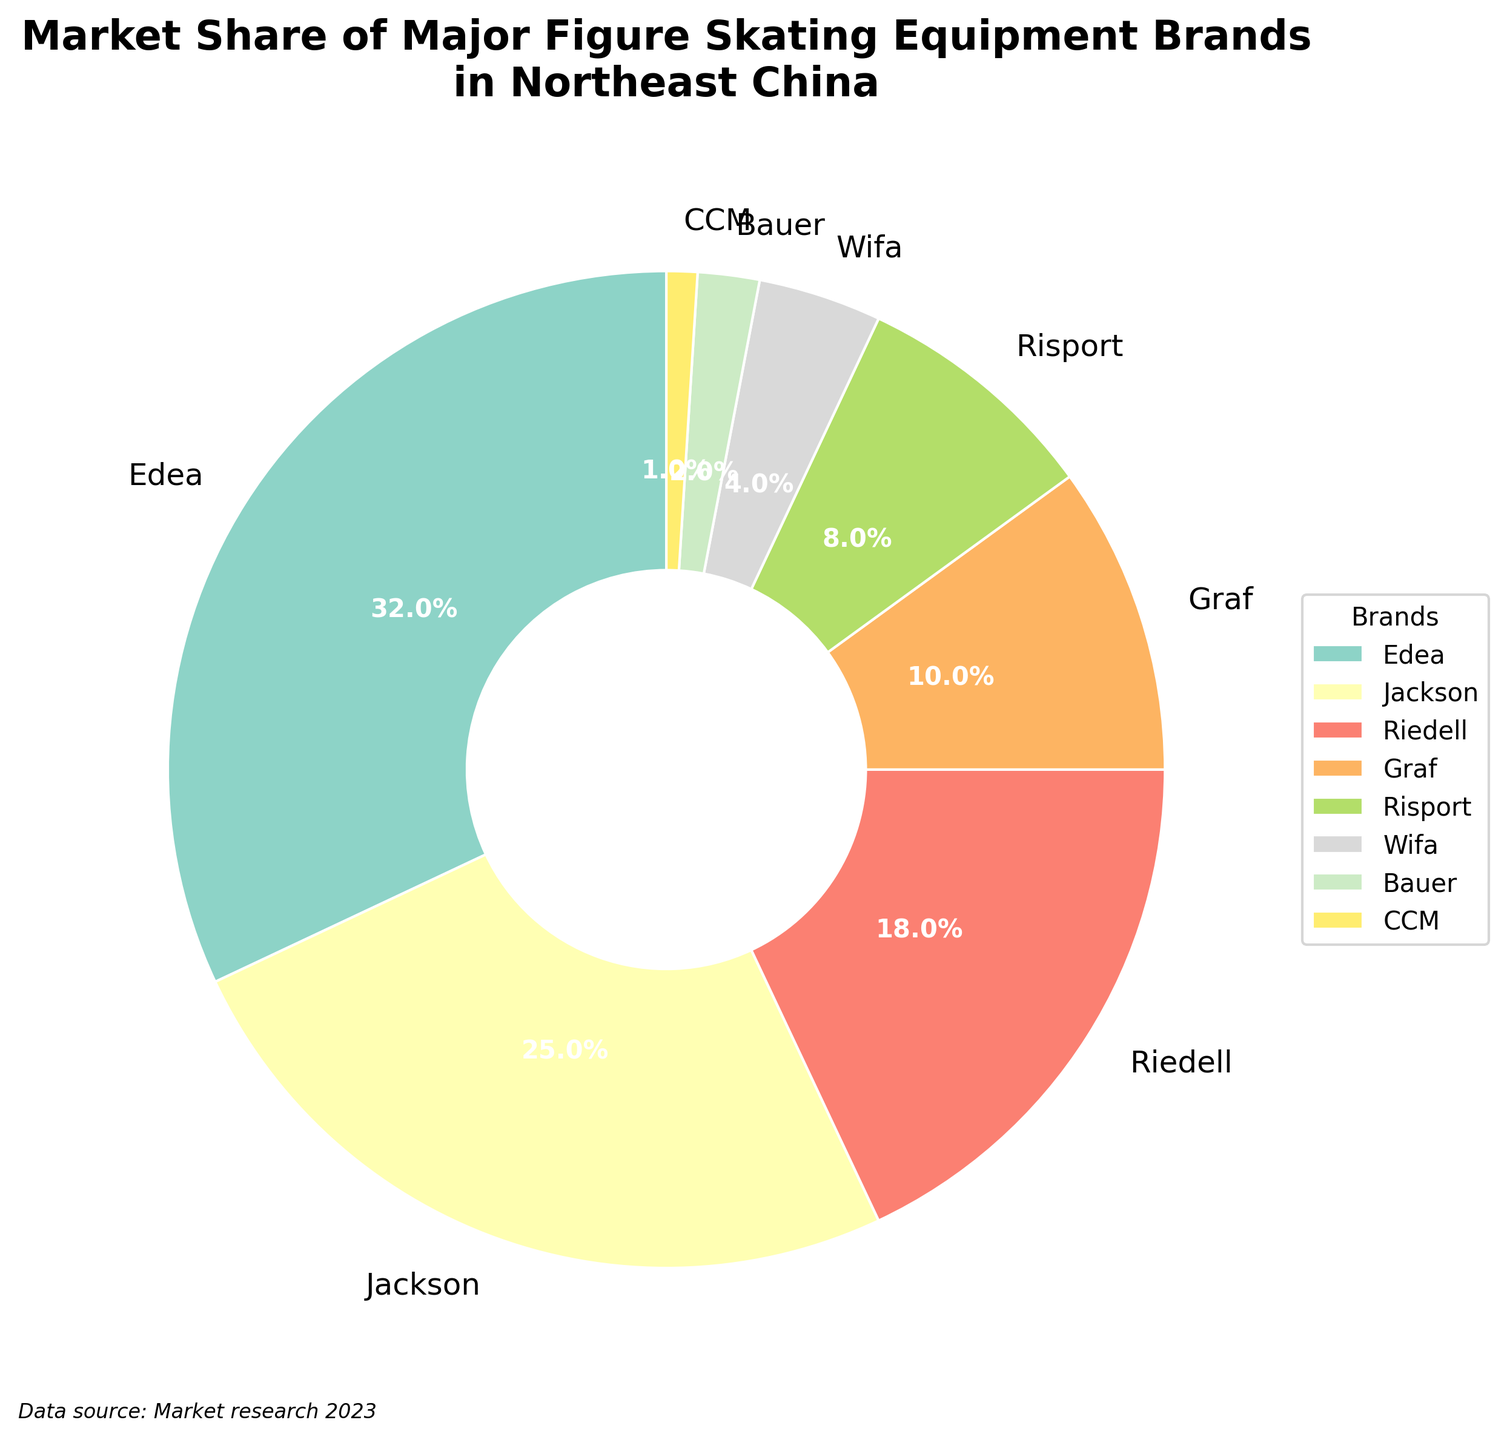Which brand has the highest market share? The brand with the largest wedge and highest market share percentage is Edea.
Answer: Edea What is the combined market share of Jackson and Riedell? Adding the market shares of Jackson and Riedell, we get 25% + 18% = 43%.
Answer: 43% How much higher is Edea's market share compared to Graf's? Edea's market share is 32%, and Graf's is 10%. The difference is 32% - 10% = 22%.
Answer: 22% Which brands have a market share less than 5%? The chart segments for Wifa, Bauer, and CCM are the smallest. Their market shares are 4%, 2%, and 1% respectively.
Answer: Wifa, Bauer, CCM What percentage of the market share is held by brands with a share bigger than 10%? The brands with a market share higher than 10% are Edea (32%), Jackson (25%), and Riedell (18%). Adding these we get 32% + 25% + 18% = 75%.
Answer: 75% Which color represent Edea on the pie chart? Look for the largest segment in the pie chart and identify its color. The segment representing 32% is characterized by a pastel hue, a typical trait of the Set3 color palette used.
Answer: See the segment with 32% Is Graf's market share closer to Riedell's or Risport's? Graf's market share is 10%, Riedell's is 18%, and Risport's is 8%. The difference between Graf and Riedell is 8% (18% - 10%) and the difference between Graf and Risport is 2% (10% - 8%), making Graf's share closer to Risport's.
Answer: Risport's How many brands have a market share of 10% or more? Count the wedges with market share labels indicating 10% or more. Those are Edea (32%), Jackson (25%), Riedell (18%), and Graf (10%). Altogether, there are 4 brands with a market share of 10% or more.
Answer: 4 If Wifa's market share increased by 3%, who would it overtake? Increasing Wifa's market share from 4% by 3% results in 7%, which would still be less than Risport's 8%. Hence, Wifa wouldn't overtake any brand.
Answer: None What is the total market share of the bottom three brands? Summing up the market shares of Bauer (2%), CCM (1%), and Wifa (4%) we get 2% + 1% + 4% = 7%.
Answer: 7% 